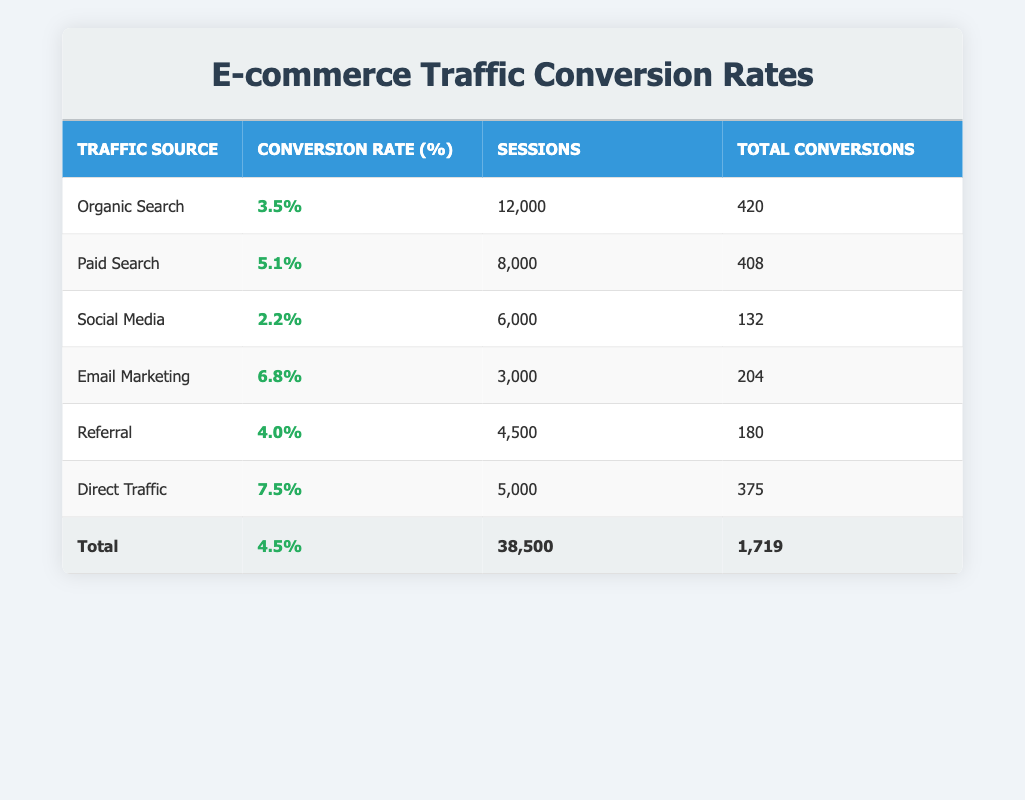What is the highest conversion rate among the traffic sources? By looking at the table, the conversion rate for Direct Traffic is listed as 7.5%, which is higher than all the other traffic sources.
Answer: 7.5% How many total sessions were recorded from all traffic sources combined? To find the total sessions, we add the session counts from each traffic source: 12000 (Organic Search) + 8000 (Paid Search) + 6000 (Social Media) + 3000 (Email Marketing) + 4500 (Referral) + 5000 (Direct Traffic) = 38500.
Answer: 38500 Which traffic source has the least total conversions? By checking the Total Conversions column, Social Media has the least total conversions with a value of 132.
Answer: 132 Is the average conversion rate for Paid Search higher than that of Organic Search? Paid Search has an average conversion rate of 5.1%, while Organic Search has an average conversion rate of 3.5%. Since 5.1% is greater than 3.5%, the statement is true.
Answer: Yes What is the total number of conversions from Email Marketing and Referral combined? The total conversions from Email Marketing are 204 and from Referral are 180. Adding these together gives: 204 + 180 = 384.
Answer: 384 Which traffic source accounted for the most conversions in relation to its session count? To find the conversion efficiency (conversions per session), we calculate: 420/12000 for Organic Search, 408/8000 for Paid Search, 132/6000 for Social Media, 204/3000 for Email Marketing, 180/4500 for Referral, and 375/5000 for Direct Traffic. The calculations reveal that Email Marketing has the highest conversions per session at 6.8% (204 conversions from 3000 sessions).
Answer: Email Marketing What is the average conversion rate across all traffic sources? We calculate the average conversion rate by summing up all the average conversion rates and dividing by the total number of sources. The values are 3.5, 5.1, 2.2, 6.8, 4.0, and 7.5. Thus, (3.5 + 5.1 + 2.2 + 6.8 + 4 + 7.5) / 6 = 4.5%.
Answer: 4.5% Is the total number of sessions for Direct Traffic less than that of Email Marketing? Direct Traffic has 5000 sessions while Email Marketing has 3000 sessions. Since 5000 is greater than 3000, the statement is false.
Answer: No 